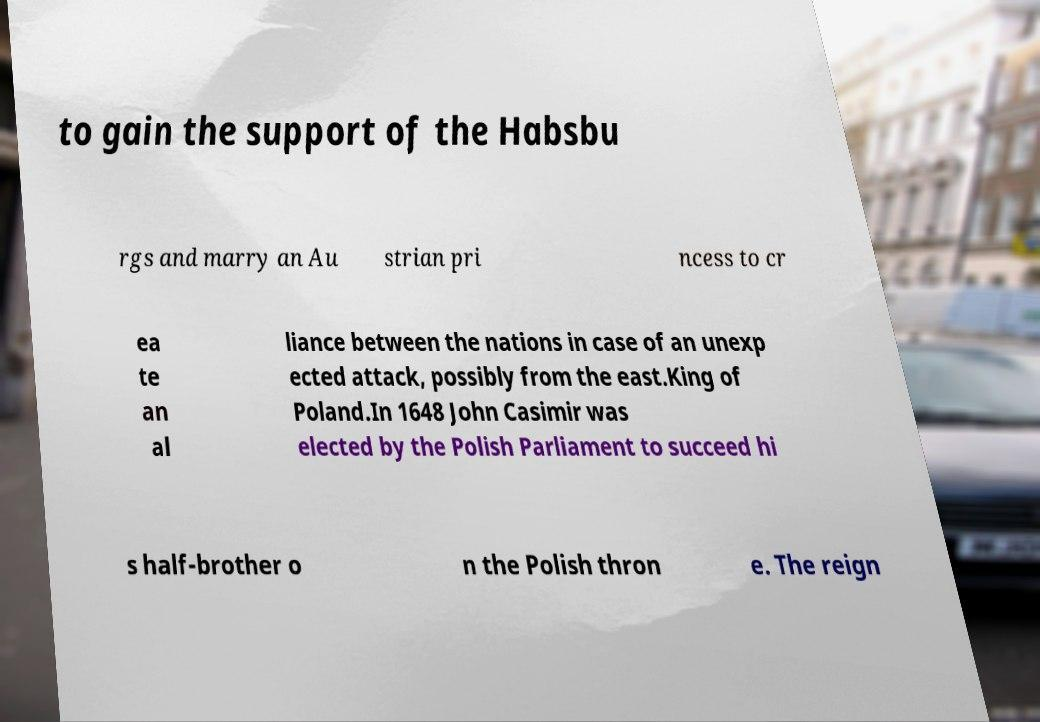For documentation purposes, I need the text within this image transcribed. Could you provide that? to gain the support of the Habsbu rgs and marry an Au strian pri ncess to cr ea te an al liance between the nations in case of an unexp ected attack, possibly from the east.King of Poland.In 1648 John Casimir was elected by the Polish Parliament to succeed hi s half-brother o n the Polish thron e. The reign 